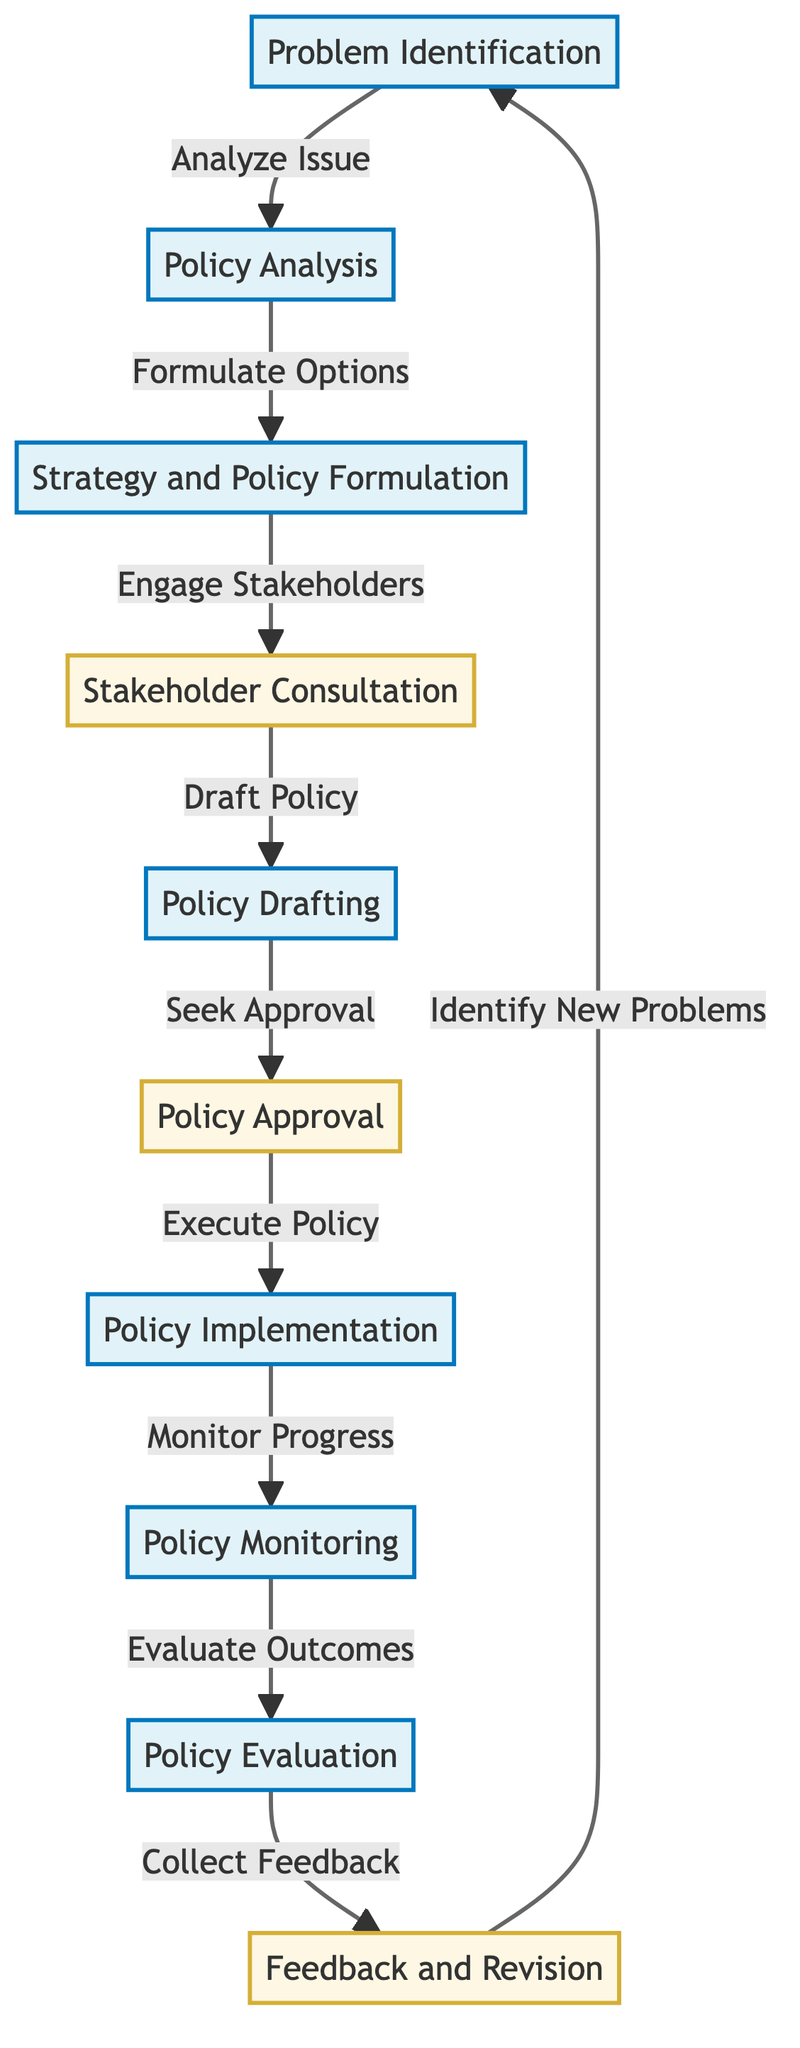What is the first step in the healthcare policy development process? The flowchart indicates that the first step is "Problem Identification." This is the starting point of the process and is represented as the first node in the diagram.
Answer: Problem Identification How many decision nodes are present in the diagram? The diagram has three decision nodes: "Stakeholder Consultation," "Policy Approval," and "Feedback and Revision." These nodes involve making choices regarding the policy process.
Answer: 3 Which step involves engaging stakeholders? The diagram identifies "Strategy and Policy Formulation" as the step that directly follows problem analysis and involves engaging stakeholders in the policy development process.
Answer: Stakeholder Consultation What connects policy analysis to strategy and policy formulation? The connection between "Policy Analysis" and "Strategy and Policy Formulation" is represented by the arrow labeled "Formulate Options," indicating that analysis leads to the development of options for policy strategy.
Answer: Formulate Options What is the last step in the process before returning to problem identification? The last step before looping back to "Problem Identification" is "Feedback and Revision," which represents taking the feedback collected and using it to address potential new problems identified in the earlier stages of the process.
Answer: Feedback and Revision How does the process proceed after policy evaluation? After "Policy Evaluation," the process moves to "Feedback and Revision." This indicates that evaluation of the policy outcomes prompts feedback collection, which can lead back to the identification of new issues.
Answer: Feedback and Revision What is the primary output of the policy approval step? The primary output of the "Policy Approval" step is "Policy Implementation," representing the transition from a proposed policy to its execution in practice once it has received approval.
Answer: Policy Implementation From which step does policy monitoring proceed? Policy monitoring directly follows "Policy Implementation" as shown in the diagram, indicating that once a policy is in place, its progress and impact are monitored.
Answer: Policy Implementation 